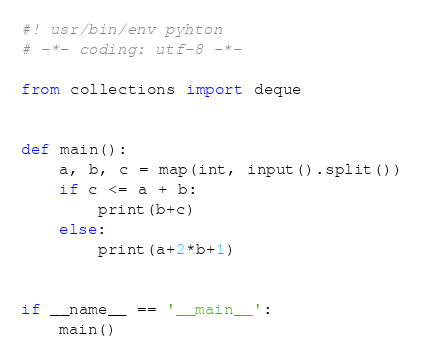Convert code to text. <code><loc_0><loc_0><loc_500><loc_500><_Python_>#! usr/bin/env pyhton
# -*- coding: utf-8 -*-

from collections import deque


def main():
    a, b, c = map(int, input().split())
    if c <= a + b:
        print(b+c)
    else:
        print(a+2*b+1)


if __name__ == '__main__':
    main()
</code> 